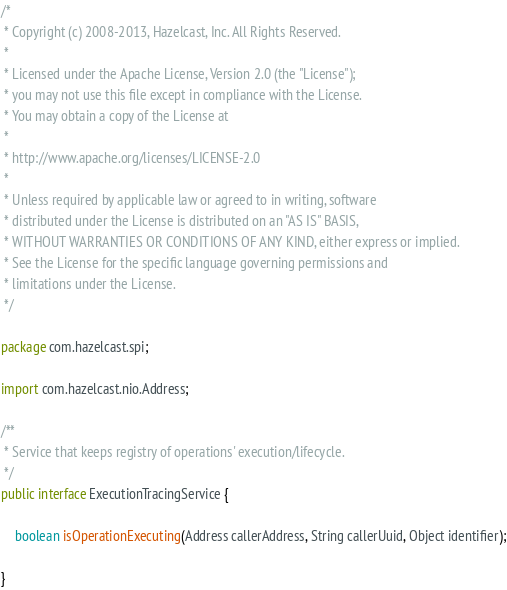<code> <loc_0><loc_0><loc_500><loc_500><_Java_>/*
 * Copyright (c) 2008-2013, Hazelcast, Inc. All Rights Reserved.
 *
 * Licensed under the Apache License, Version 2.0 (the "License");
 * you may not use this file except in compliance with the License.
 * You may obtain a copy of the License at
 *
 * http://www.apache.org/licenses/LICENSE-2.0
 *
 * Unless required by applicable law or agreed to in writing, software
 * distributed under the License is distributed on an "AS IS" BASIS,
 * WITHOUT WARRANTIES OR CONDITIONS OF ANY KIND, either express or implied.
 * See the License for the specific language governing permissions and
 * limitations under the License.
 */

package com.hazelcast.spi;

import com.hazelcast.nio.Address;

/**
 * Service that keeps registry of operations' execution/lifecycle.
 */
public interface ExecutionTracingService {

    boolean isOperationExecuting(Address callerAddress, String callerUuid, Object identifier);

}
</code> 